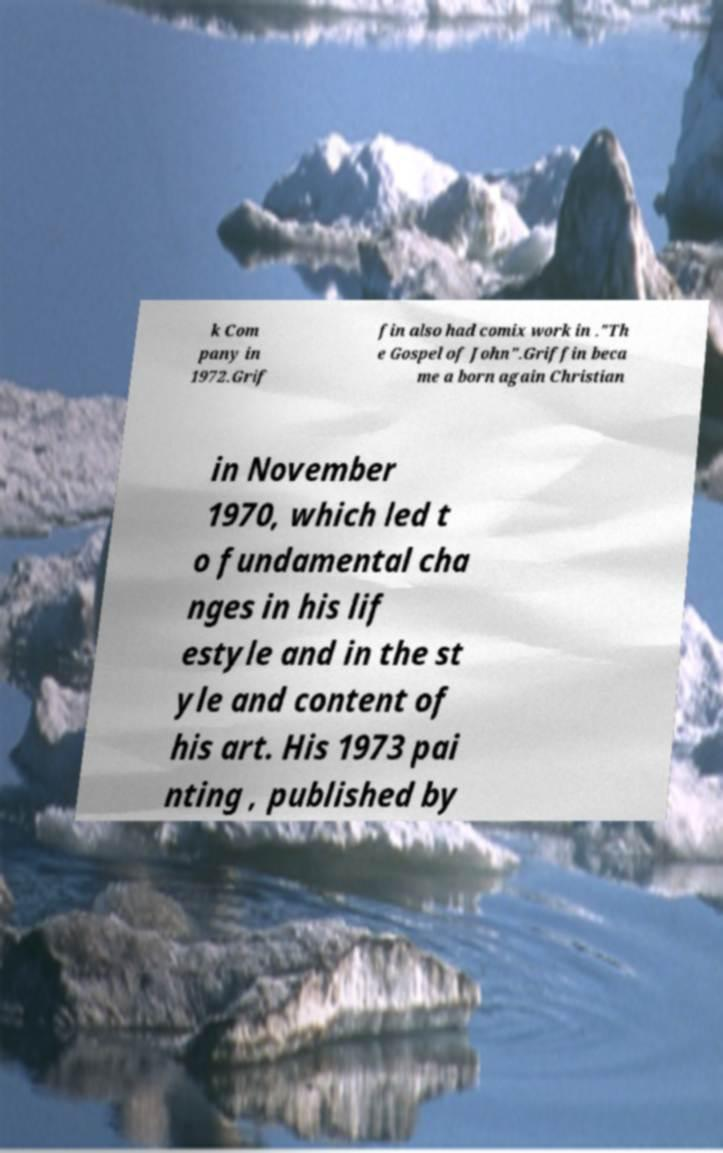There's text embedded in this image that I need extracted. Can you transcribe it verbatim? k Com pany in 1972.Grif fin also had comix work in ."Th e Gospel of John".Griffin beca me a born again Christian in November 1970, which led t o fundamental cha nges in his lif estyle and in the st yle and content of his art. His 1973 pai nting , published by 